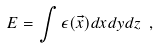Convert formula to latex. <formula><loc_0><loc_0><loc_500><loc_500>E = \int \epsilon ( \vec { x } ) d x d y d z \ ,</formula> 